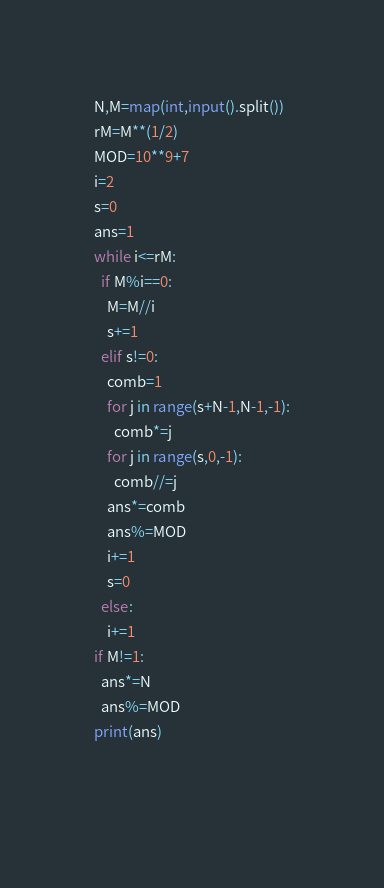Convert code to text. <code><loc_0><loc_0><loc_500><loc_500><_Python_>N,M=map(int,input().split())
rM=M**(1/2)
MOD=10**9+7
i=2
s=0
ans=1
while i<=rM:
  if M%i==0:
    M=M//i
    s+=1
  elif s!=0:
    comb=1
    for j in range(s+N-1,N-1,-1):
      comb*=j
    for j in range(s,0,-1):
      comb//=j
    ans*=comb
    ans%=MOD
    i+=1
    s=0
  else:
    i+=1
if M!=1:
  ans*=N
  ans%=MOD
print(ans)
    
  </code> 